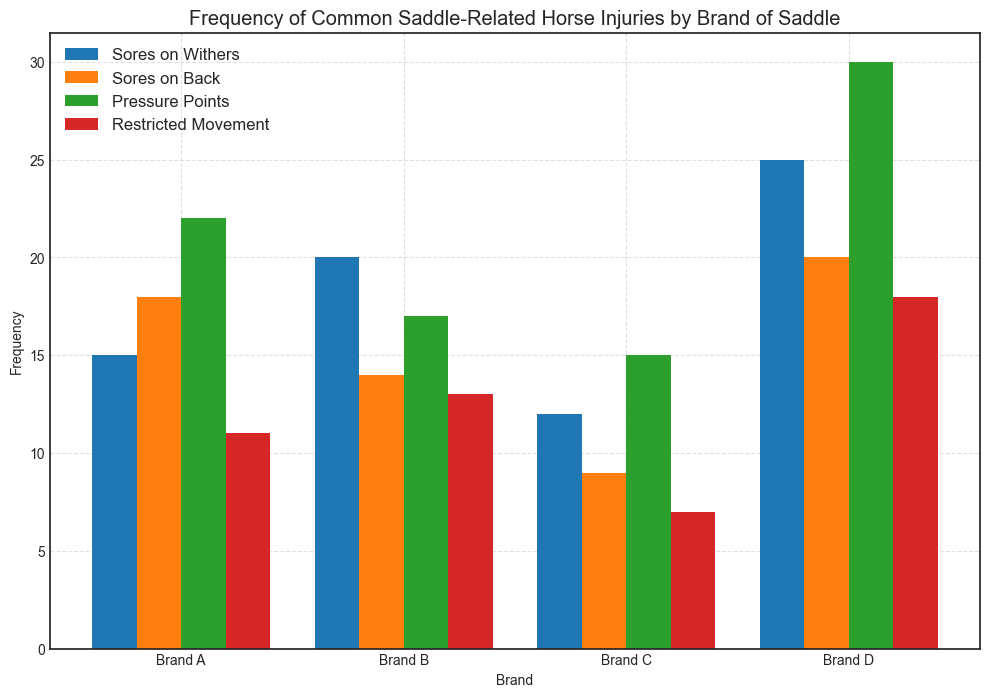What is the frequency of 'Sores on Withers' for Brand A? To find the frequency of 'Sores on Withers' for Brand A, look at the height of the corresponding bar for Brand A in the figure. The height of the bar represents the frequency.
Answer: 15 Which brand has the highest frequency of 'Pressure Points'? Compare the heights of the bars corresponding to 'Pressure Points' for all brands. The tallest bar indicates the highest frequency.
Answer: Brand D What is the difference in frequency of 'Restricted Movement' between Brand B and Brand C? Subtract the frequency of 'Restricted Movement' for Brand C from that for Brand B by looking at the respective bar heights. Brand B frequency is 13 and Brand C frequency is 7, so the difference is 13 - 7.
Answer: 6 Which injury type has the lowest frequency for Brand D? Among the four injury types for Brand D, the one with the shortest bar represents the lowest frequency. Compare the bar heights for 'Sores on Withers', 'Sores on Back', 'Pressure Points', and 'Restricted Movement'.
Answer: Restricted Movement Which brand has the lowest average frequency across all injury types? First, calculate the average frequency for each brand by summing the frequencies of all injury types and then dividing by the number of types (which is 4). Compare the averages for each brand. For Brand A: (15 + 18 + 22 + 11) / 4 = 16.5. For Brand B: (20 + 14 + 17 + 13) / 4 = 16. For Brand C: (12 + 9 + 15 + 7) / 4 = 10.75. For Brand D: (25 + 20 + 30 + 18) / 4 = 23.25. The lowest average is 10.75.
Answer: Brand C How does the frequency of 'Sores on Back' compare between Brand A and Brand D? Compare the bar heights for 'Sores on Back' for Brand A and Brand D. The height for Brand A is 18 and for Brand D is 20.
Answer: Brand A has a lower frequency than Brand D What is the total frequency of 'Sores on Withers' across all brands? Add up the frequencies of 'Sores on Withers' for all brands. The frequencies are 15 for Brand A, 20 for Brand B, 12 for Brand C, and 25 for Brand D. (15 + 20 + 12 + 25) = 72.
Answer: 72 Which brand shows the greatest variation in frequency across different injury types? Determine the range (difference between highest and lowest frequency) for each brand. For Brand A, the range is (22 - 11) = 11. For Brand B, the range is (20 - 13) = 7. For Brand C, the range is (15 - 7) = 8. For Brand D, the range is (30 - 18) = 12. The greatest range is 12 for Brand D.
Answer: Brand D What is the combined frequency of 'Pressure Points' and 'Restricted Movement' for Brand C? Add the frequencies of 'Pressure Points' and 'Restricted Movement' for Brand C by summing the respective bar heights. (15 + 7) = 22.
Answer: 22 